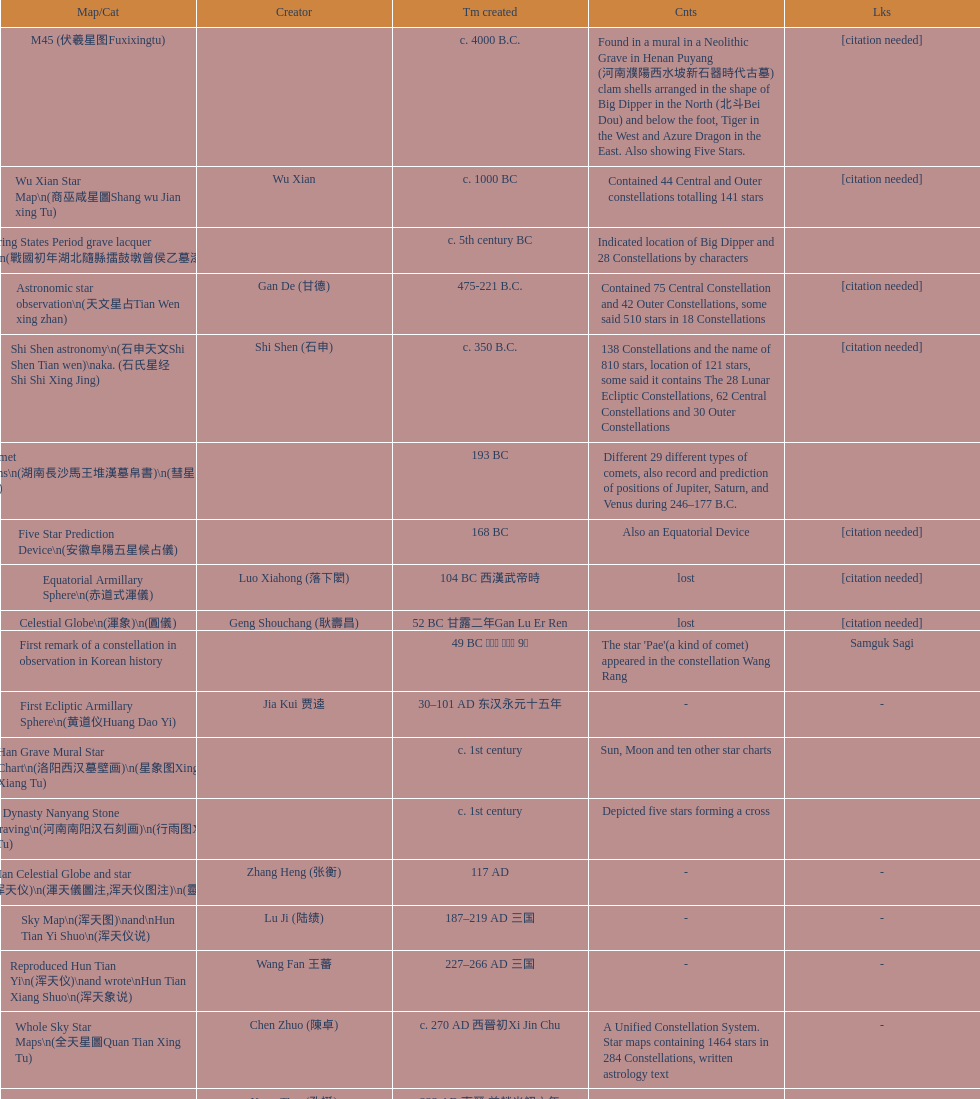Did xu guang ci or su song create the five star charts in 1094 ad? Su Song 蘇頌. 